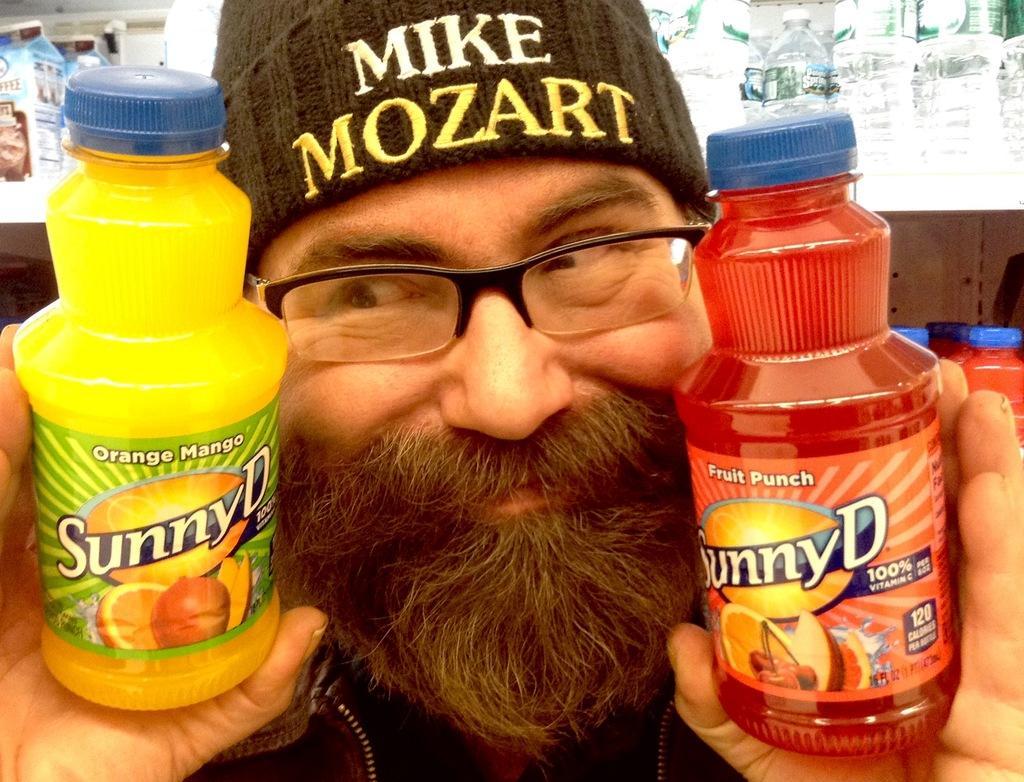Please provide a concise description of this image. In the image we can see there is a person who is standing and he is holding two juice bottles which are in red and yellow colour. He is wearing a cap and at the back in the shelf there are water bottles and cans. 